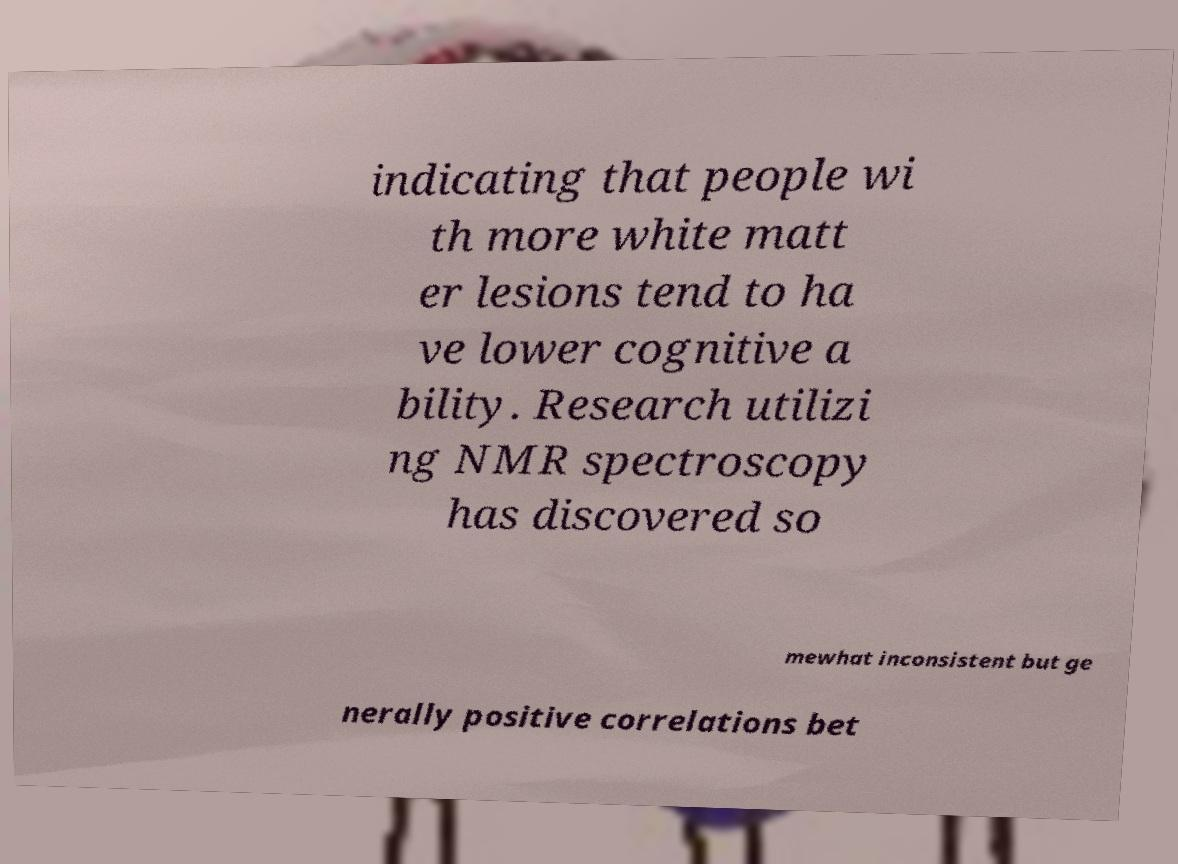What messages or text are displayed in this image? I need them in a readable, typed format. indicating that people wi th more white matt er lesions tend to ha ve lower cognitive a bility. Research utilizi ng NMR spectroscopy has discovered so mewhat inconsistent but ge nerally positive correlations bet 